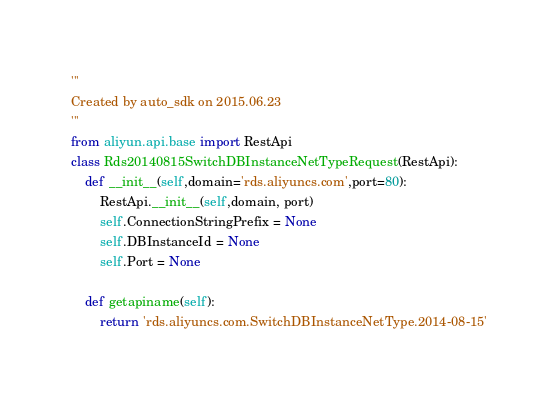Convert code to text. <code><loc_0><loc_0><loc_500><loc_500><_Python_>'''
Created by auto_sdk on 2015.06.23
'''
from aliyun.api.base import RestApi
class Rds20140815SwitchDBInstanceNetTypeRequest(RestApi):
	def __init__(self,domain='rds.aliyuncs.com',port=80):
		RestApi.__init__(self,domain, port)
		self.ConnectionStringPrefix = None
		self.DBInstanceId = None
		self.Port = None

	def getapiname(self):
		return 'rds.aliyuncs.com.SwitchDBInstanceNetType.2014-08-15'
</code> 